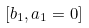Convert formula to latex. <formula><loc_0><loc_0><loc_500><loc_500>[ b _ { 1 } , a _ { 1 } = 0 ]</formula> 